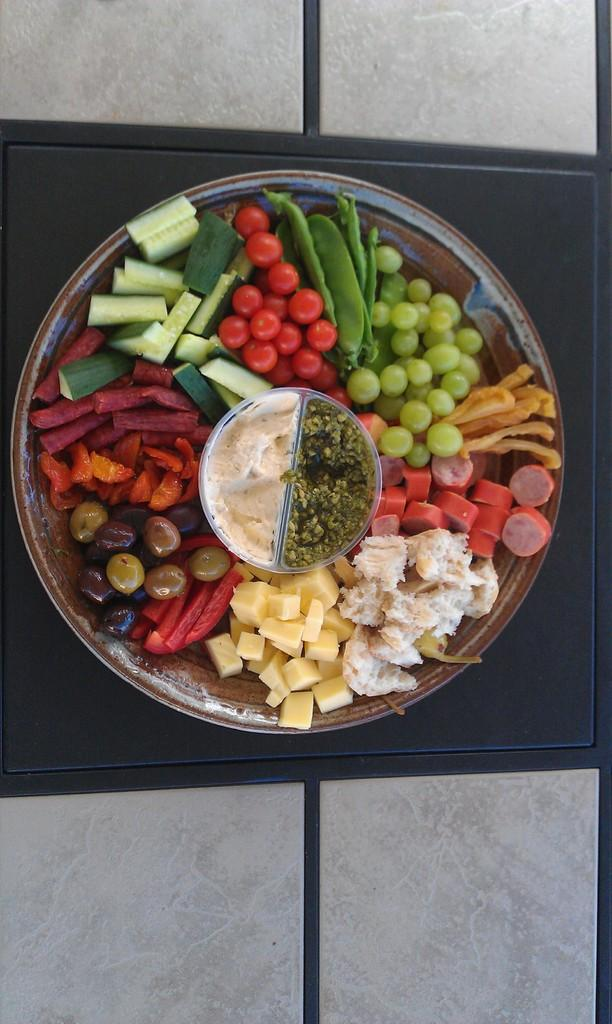What is located in the center of the image? There is a plate in the center of the image. What is on the plate? There are fruits on the plate. What can be seen in the background of the image? There is a table in the background of the image. What type of straw is used to hold the fruits together in the image? There is no straw present in the image; the fruits are simply placed on the plate. 